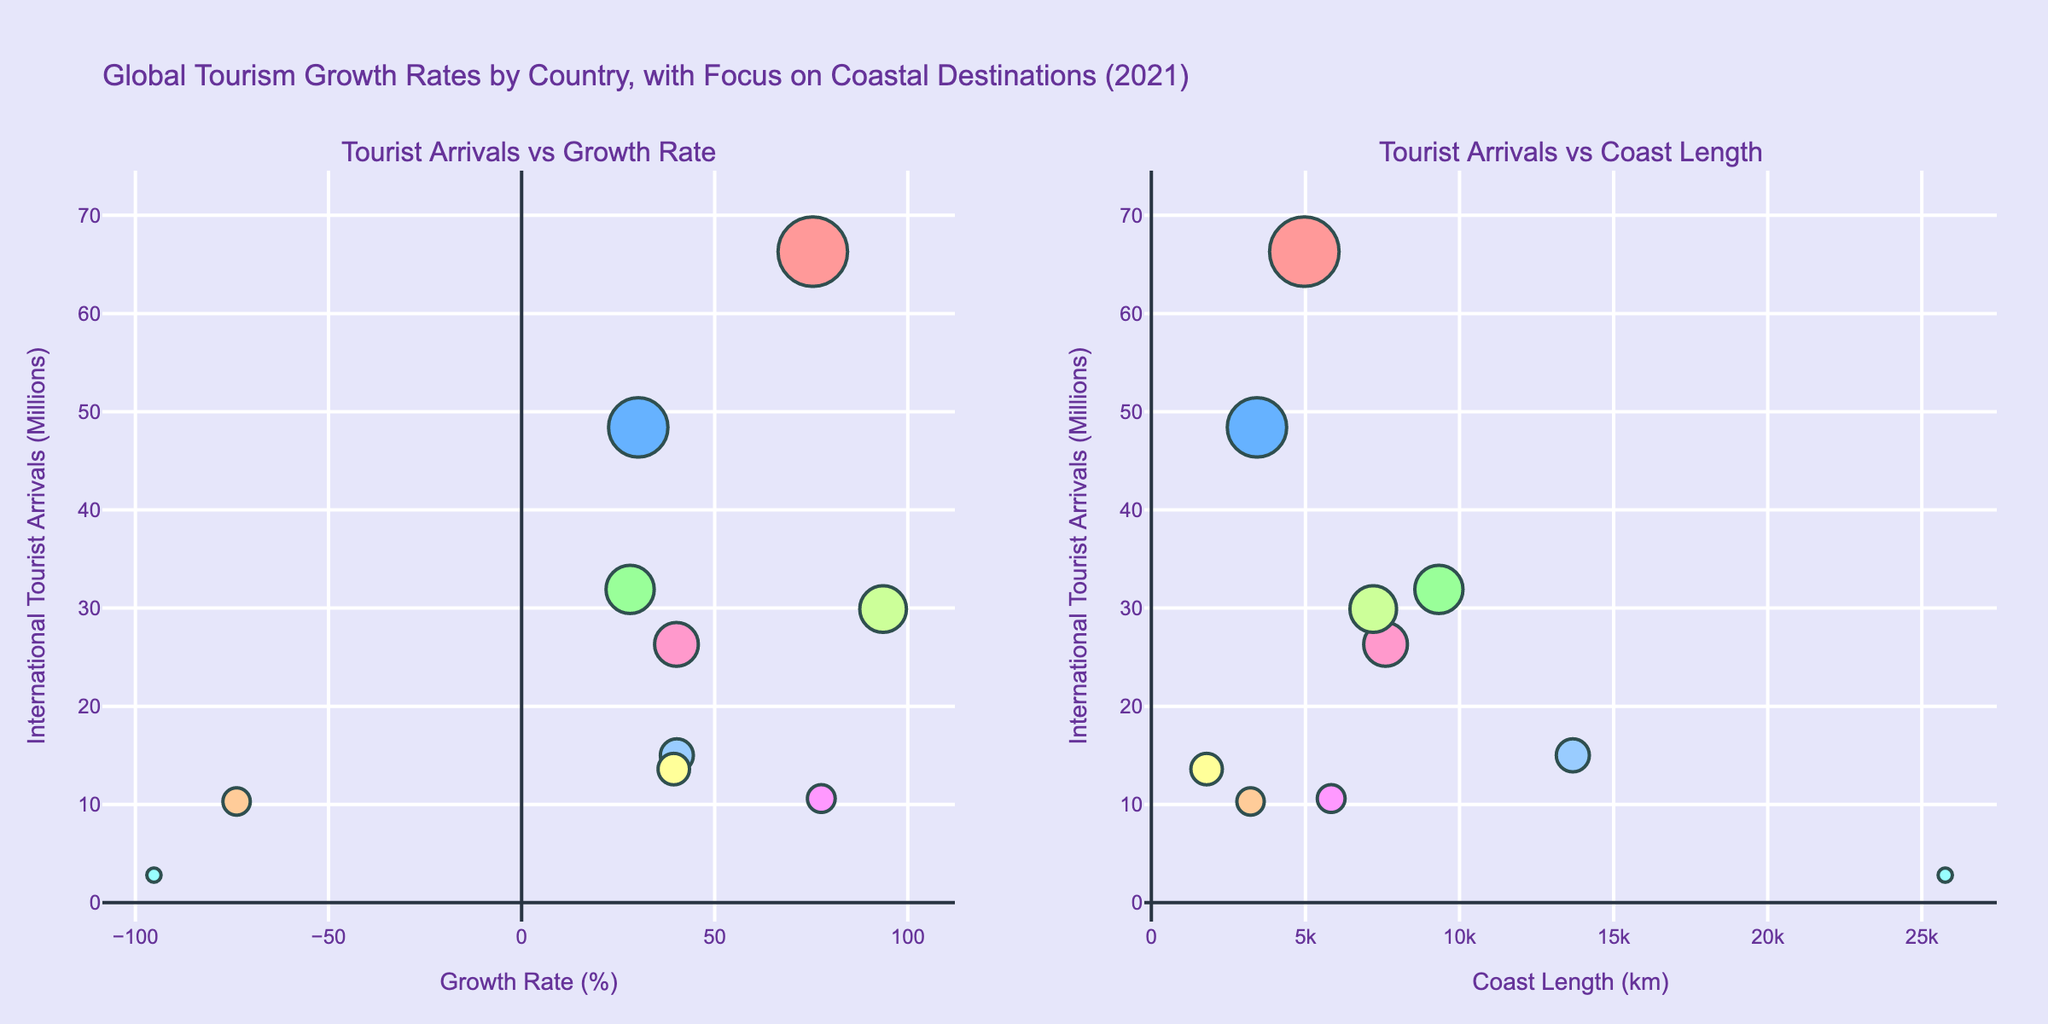what is the title of the chart? The title is displayed at the top of the chart. It reads, "Global Tourism Growth Rates by Country, with Focus on Coastal Destinations (2021)."
Answer: Global Tourism Growth Rates by Country, with Focus on Coastal Destinations (2021) How are the subplots titled? The figure contains two subplots, with titles displayed above each subplot. The left subplot is titled "Tourist Arrivals vs Growth Rate" and the right subplot is titled "Tourist Arrivals vs Coast Length."
Answer: Tourist Arrivals vs Growth Rate, Tourist Arrivals vs Coast Length Which country has the highest growth rate in the left subplot? On the left subplot, the Growth Rate is plotted on the X-axis. The bubble with the highest value on the X-axis corresponds to Turkey.
Answer: Turkey In the left subplot, which country has the lowest tourist arrivals? On the left subplot, International Tourist Arrivals is plotted on the Y-axis. The smallest value on the Y-axis corresponds to Australia.
Answer: Australia How many countries show a negative growth rate? The left subplot, with Growth Rate on the X-axis, shows that Thailand and Australia have negative growth rates, as their bubbles are to the left of the zero mark.
Answer: 2 Compare the growth rates of Spain and Croatia. In the left subplot, Spain and Croatia's bubbles are compared on the Growth Rate axis (X-axis). Spain has a growth rate of 75.4%, whereas Croatia has a higher growth rate of 77.6%.
Answer: Croatia has a higher growth rate than Spain Which country has the longest coastline? The X-axis of the right subplot indicates Coast Length. The bubble furthest to the right represents Australia, which has the longest coastline.
Answer: Australia Which country received more international tourists, Greece or Italy? On both subplots, Italy's bubble is positioned higher on the Y-axis (International Tourist Arrivals) than Greece's bubble.
Answer: Italy What is the relationship between coast length and tourist arrivals in the right subplot? Observing the right subplot, there doesn't appear to be a clear linear relationship between the Coast Length (X-axis) and International Tourist Arrivals (Y-axis) as countries with short and long coastlines have varying tourist numbers.
Answer: No clear relationship Which country's bubble has the largest size? The size of the bubbles represents the number of international tourist arrivals, with larger bubbles indicating more arrivals. The largest bubble corresponds to Spain, which had the most tourist arrivals.
Answer: Spain 